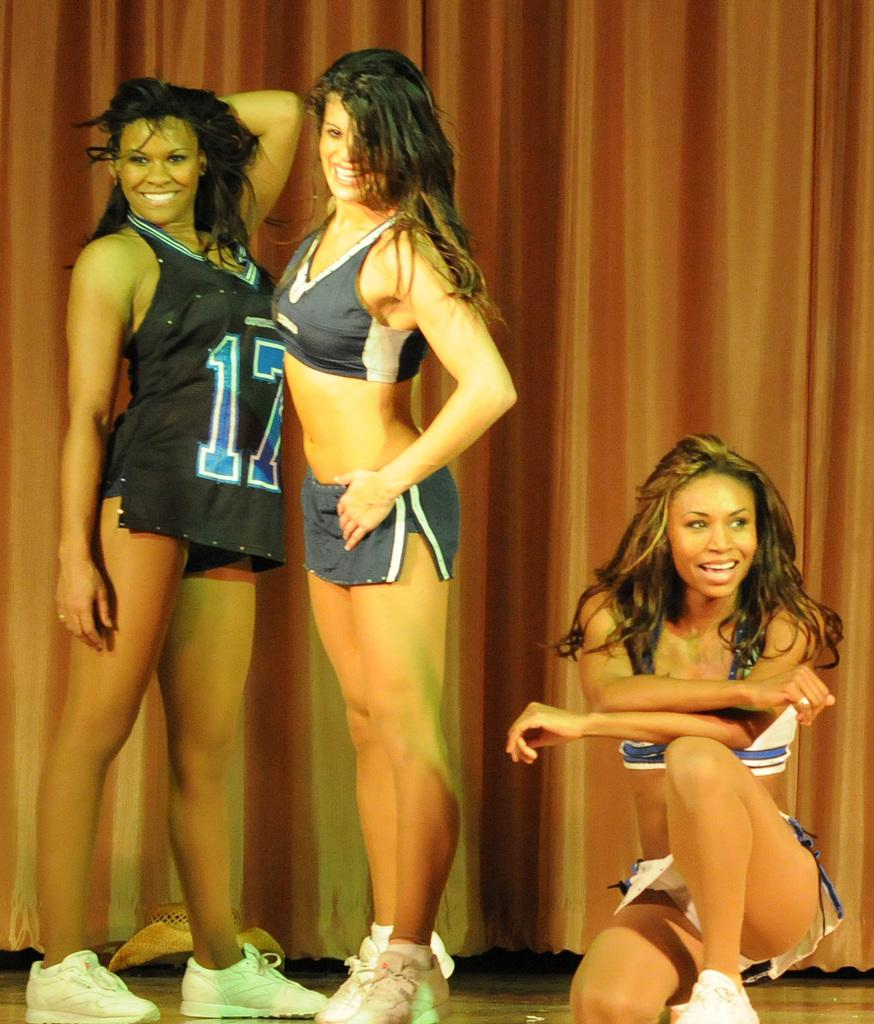Provide a one-sentence caption for the provided image. three women standing on a stage in front of a curtain, one is wearing a number 17 jersey. 